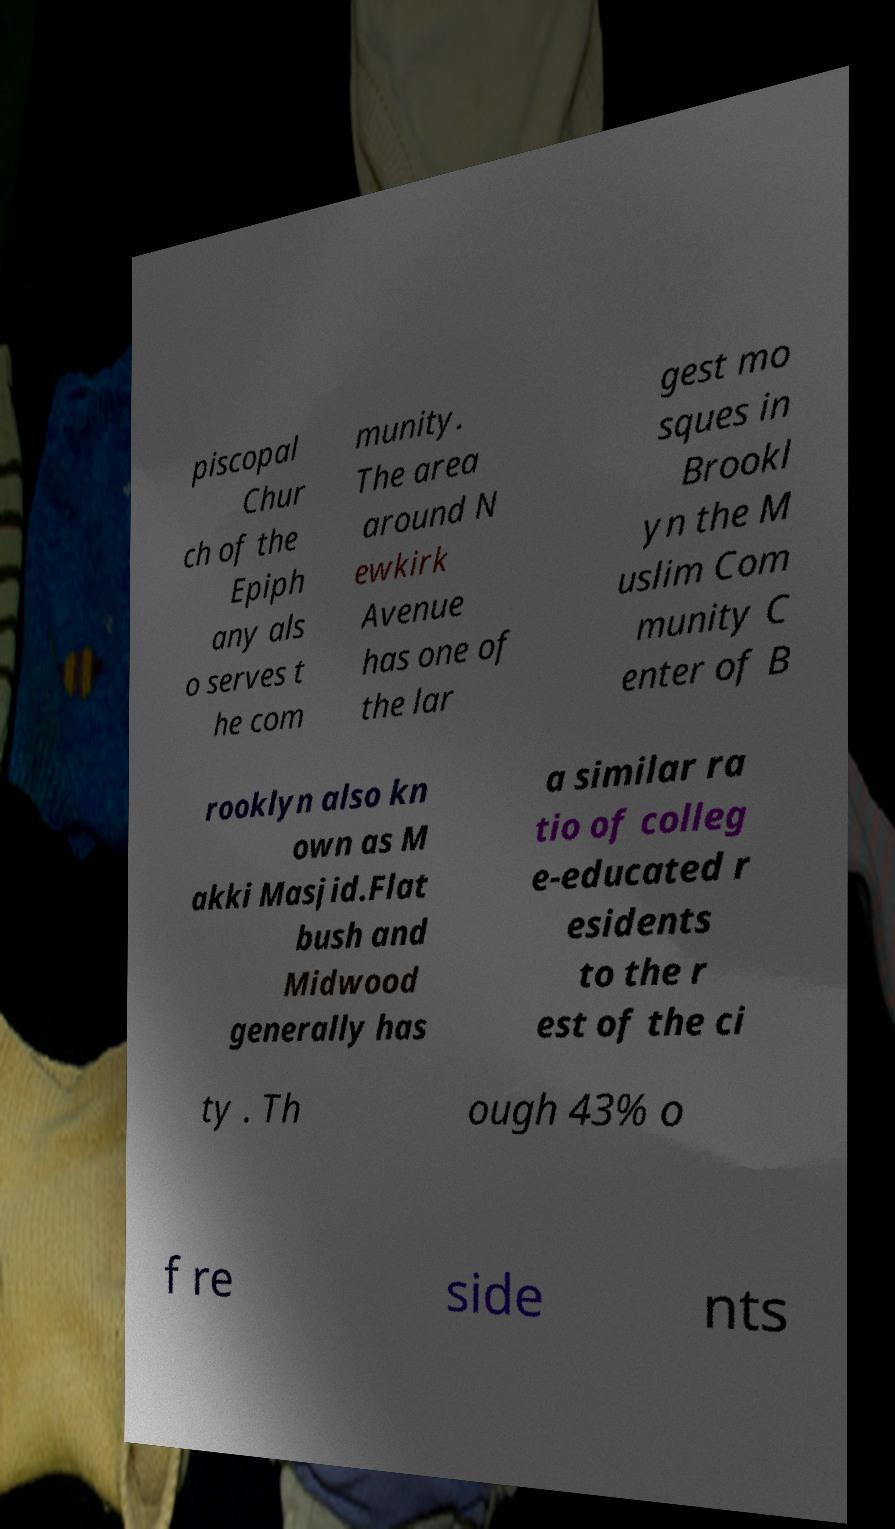I need the written content from this picture converted into text. Can you do that? piscopal Chur ch of the Epiph any als o serves t he com munity. The area around N ewkirk Avenue has one of the lar gest mo sques in Brookl yn the M uslim Com munity C enter of B rooklyn also kn own as M akki Masjid.Flat bush and Midwood generally has a similar ra tio of colleg e-educated r esidents to the r est of the ci ty . Th ough 43% o f re side nts 